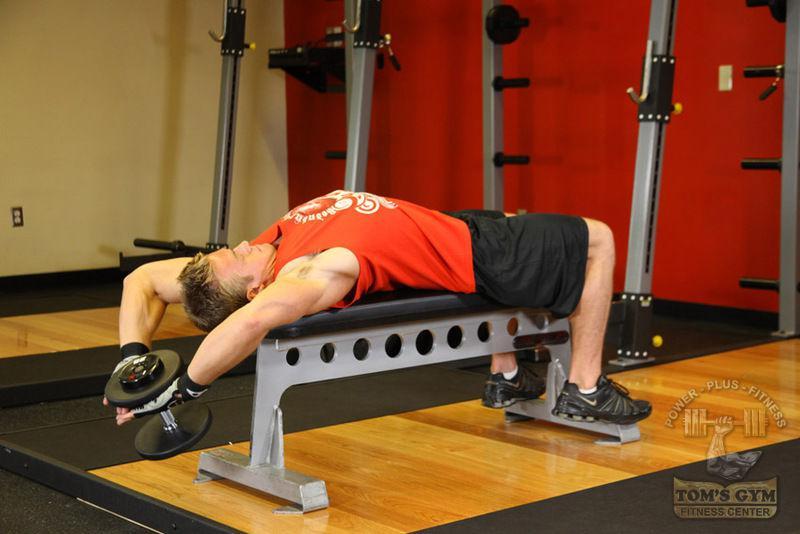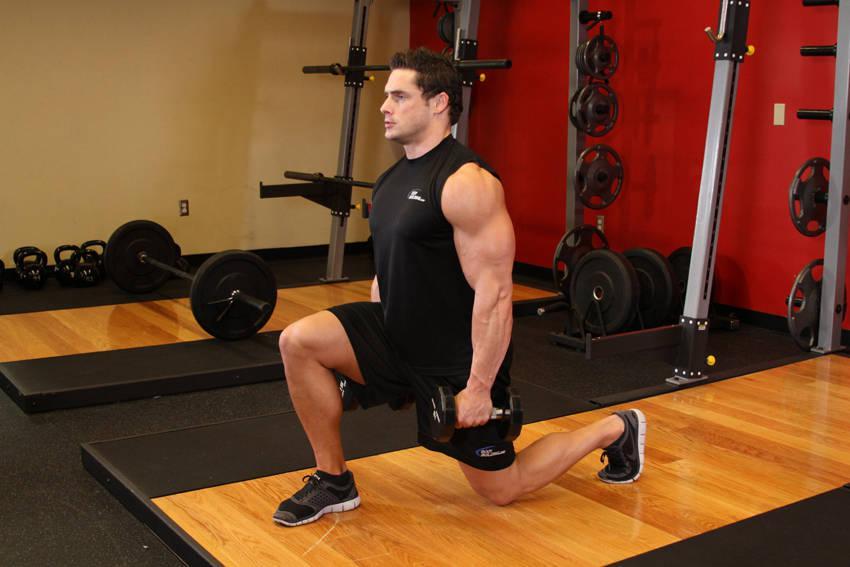The first image is the image on the left, the second image is the image on the right. For the images shown, is this caption "There is a man dressed in black shorts and a red shirt in one of the images" true? Answer yes or no. Yes. 